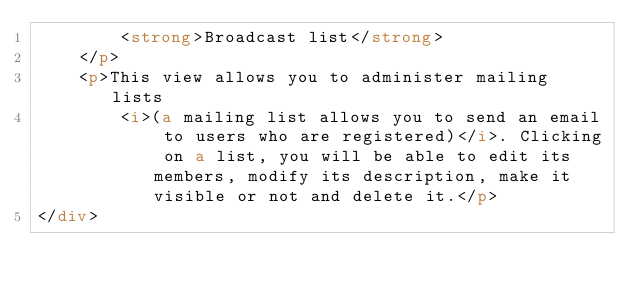Convert code to text. <code><loc_0><loc_0><loc_500><loc_500><_HTML_>        <strong>Broadcast list</strong>
    </p>
    <p>This view allows you to administer mailing lists
        <i>(a mailing list allows you to send an email to users who are registered)</i>. Clicking on a list, you will be able to edit its members, modify its description, make it visible or not and delete it.</p>
</div></code> 